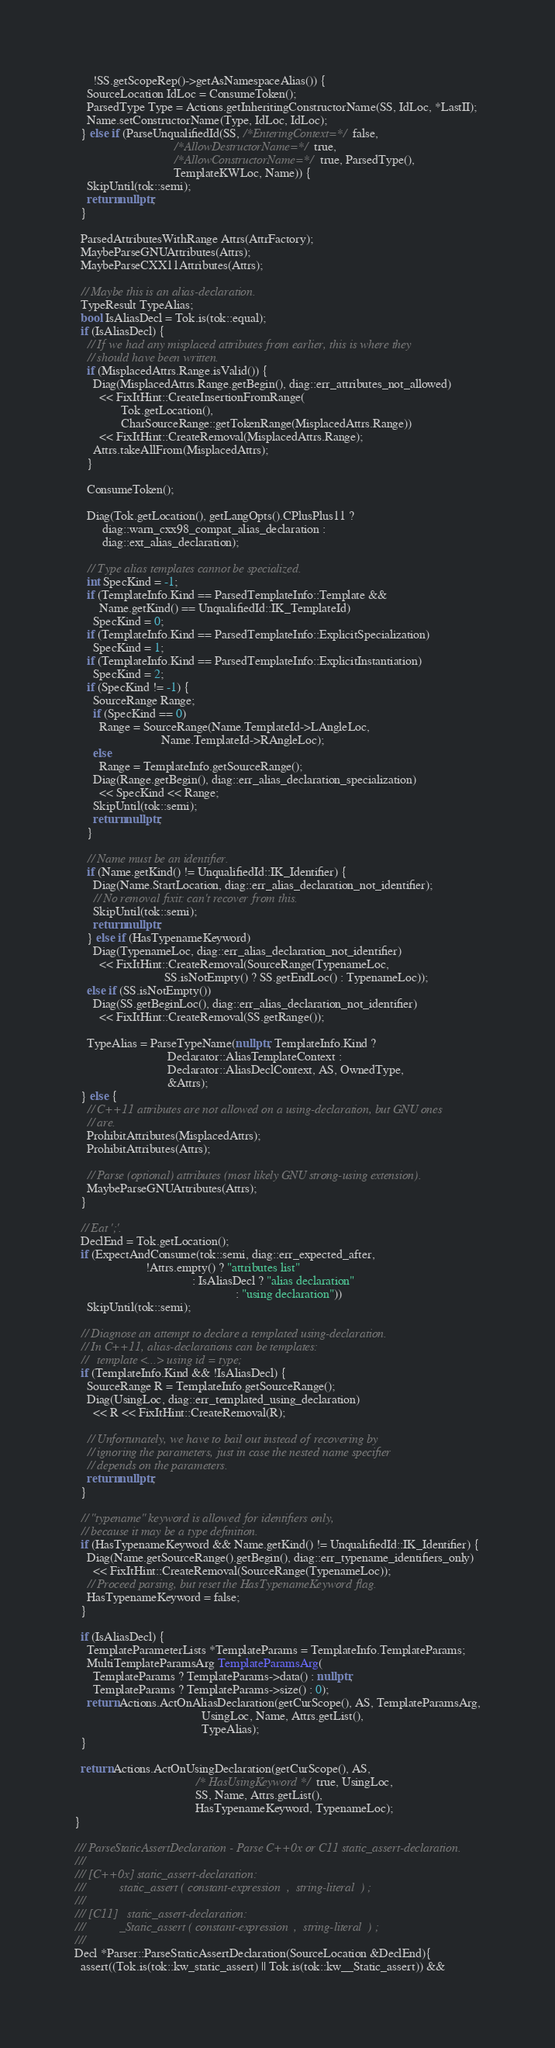Convert code to text. <code><loc_0><loc_0><loc_500><loc_500><_C++_>      !SS.getScopeRep()->getAsNamespaceAlias()) {
    SourceLocation IdLoc = ConsumeToken();
    ParsedType Type = Actions.getInheritingConstructorName(SS, IdLoc, *LastII);
    Name.setConstructorName(Type, IdLoc, IdLoc);
  } else if (ParseUnqualifiedId(SS, /*EnteringContext=*/ false,
                                /*AllowDestructorName=*/ true,
                                /*AllowConstructorName=*/ true, ParsedType(),
                                TemplateKWLoc, Name)) {
    SkipUntil(tok::semi);
    return nullptr;
  }

  ParsedAttributesWithRange Attrs(AttrFactory);
  MaybeParseGNUAttributes(Attrs);
  MaybeParseCXX11Attributes(Attrs);

  // Maybe this is an alias-declaration.
  TypeResult TypeAlias;
  bool IsAliasDecl = Tok.is(tok::equal);
  if (IsAliasDecl) {
    // If we had any misplaced attributes from earlier, this is where they
    // should have been written.
    if (MisplacedAttrs.Range.isValid()) {
      Diag(MisplacedAttrs.Range.getBegin(), diag::err_attributes_not_allowed)
        << FixItHint::CreateInsertionFromRange(
               Tok.getLocation(),
               CharSourceRange::getTokenRange(MisplacedAttrs.Range))
        << FixItHint::CreateRemoval(MisplacedAttrs.Range);
      Attrs.takeAllFrom(MisplacedAttrs);
    }

    ConsumeToken();

    Diag(Tok.getLocation(), getLangOpts().CPlusPlus11 ?
         diag::warn_cxx98_compat_alias_declaration :
         diag::ext_alias_declaration);

    // Type alias templates cannot be specialized.
    int SpecKind = -1;
    if (TemplateInfo.Kind == ParsedTemplateInfo::Template &&
        Name.getKind() == UnqualifiedId::IK_TemplateId)
      SpecKind = 0;
    if (TemplateInfo.Kind == ParsedTemplateInfo::ExplicitSpecialization)
      SpecKind = 1;
    if (TemplateInfo.Kind == ParsedTemplateInfo::ExplicitInstantiation)
      SpecKind = 2;
    if (SpecKind != -1) {
      SourceRange Range;
      if (SpecKind == 0)
        Range = SourceRange(Name.TemplateId->LAngleLoc,
                            Name.TemplateId->RAngleLoc);
      else
        Range = TemplateInfo.getSourceRange();
      Diag(Range.getBegin(), diag::err_alias_declaration_specialization)
        << SpecKind << Range;
      SkipUntil(tok::semi);
      return nullptr;
    }

    // Name must be an identifier.
    if (Name.getKind() != UnqualifiedId::IK_Identifier) {
      Diag(Name.StartLocation, diag::err_alias_declaration_not_identifier);
      // No removal fixit: can't recover from this.
      SkipUntil(tok::semi);
      return nullptr;
    } else if (HasTypenameKeyword)
      Diag(TypenameLoc, diag::err_alias_declaration_not_identifier)
        << FixItHint::CreateRemoval(SourceRange(TypenameLoc,
                             SS.isNotEmpty() ? SS.getEndLoc() : TypenameLoc));
    else if (SS.isNotEmpty())
      Diag(SS.getBeginLoc(), diag::err_alias_declaration_not_identifier)
        << FixItHint::CreateRemoval(SS.getRange());

    TypeAlias = ParseTypeName(nullptr, TemplateInfo.Kind ?
                              Declarator::AliasTemplateContext :
                              Declarator::AliasDeclContext, AS, OwnedType,
                              &Attrs);
  } else {
    // C++11 attributes are not allowed on a using-declaration, but GNU ones
    // are.
    ProhibitAttributes(MisplacedAttrs);
    ProhibitAttributes(Attrs);

    // Parse (optional) attributes (most likely GNU strong-using extension).
    MaybeParseGNUAttributes(Attrs);
  }

  // Eat ';'.
  DeclEnd = Tok.getLocation();
  if (ExpectAndConsume(tok::semi, diag::err_expected_after,
                       !Attrs.empty() ? "attributes list"
                                      : IsAliasDecl ? "alias declaration"
                                                    : "using declaration"))
    SkipUntil(tok::semi);

  // Diagnose an attempt to declare a templated using-declaration.
  // In C++11, alias-declarations can be templates:
  //   template <...> using id = type;
  if (TemplateInfo.Kind && !IsAliasDecl) {
    SourceRange R = TemplateInfo.getSourceRange();
    Diag(UsingLoc, diag::err_templated_using_declaration)
      << R << FixItHint::CreateRemoval(R);

    // Unfortunately, we have to bail out instead of recovering by
    // ignoring the parameters, just in case the nested name specifier
    // depends on the parameters.
    return nullptr;
  }

  // "typename" keyword is allowed for identifiers only,
  // because it may be a type definition.
  if (HasTypenameKeyword && Name.getKind() != UnqualifiedId::IK_Identifier) {
    Diag(Name.getSourceRange().getBegin(), diag::err_typename_identifiers_only)
      << FixItHint::CreateRemoval(SourceRange(TypenameLoc));
    // Proceed parsing, but reset the HasTypenameKeyword flag.
    HasTypenameKeyword = false;
  }

  if (IsAliasDecl) {
    TemplateParameterLists *TemplateParams = TemplateInfo.TemplateParams;
    MultiTemplateParamsArg TemplateParamsArg(
      TemplateParams ? TemplateParams->data() : nullptr,
      TemplateParams ? TemplateParams->size() : 0);
    return Actions.ActOnAliasDeclaration(getCurScope(), AS, TemplateParamsArg,
                                         UsingLoc, Name, Attrs.getList(),
                                         TypeAlias);
  }

  return Actions.ActOnUsingDeclaration(getCurScope(), AS,
                                       /* HasUsingKeyword */ true, UsingLoc,
                                       SS, Name, Attrs.getList(),
                                       HasTypenameKeyword, TypenameLoc);
}

/// ParseStaticAssertDeclaration - Parse C++0x or C11 static_assert-declaration.
///
/// [C++0x] static_assert-declaration:
///           static_assert ( constant-expression  ,  string-literal  ) ;
///
/// [C11]   static_assert-declaration:
///           _Static_assert ( constant-expression  ,  string-literal  ) ;
///
Decl *Parser::ParseStaticAssertDeclaration(SourceLocation &DeclEnd){
  assert((Tok.is(tok::kw_static_assert) || Tok.is(tok::kw__Static_assert)) &&</code> 